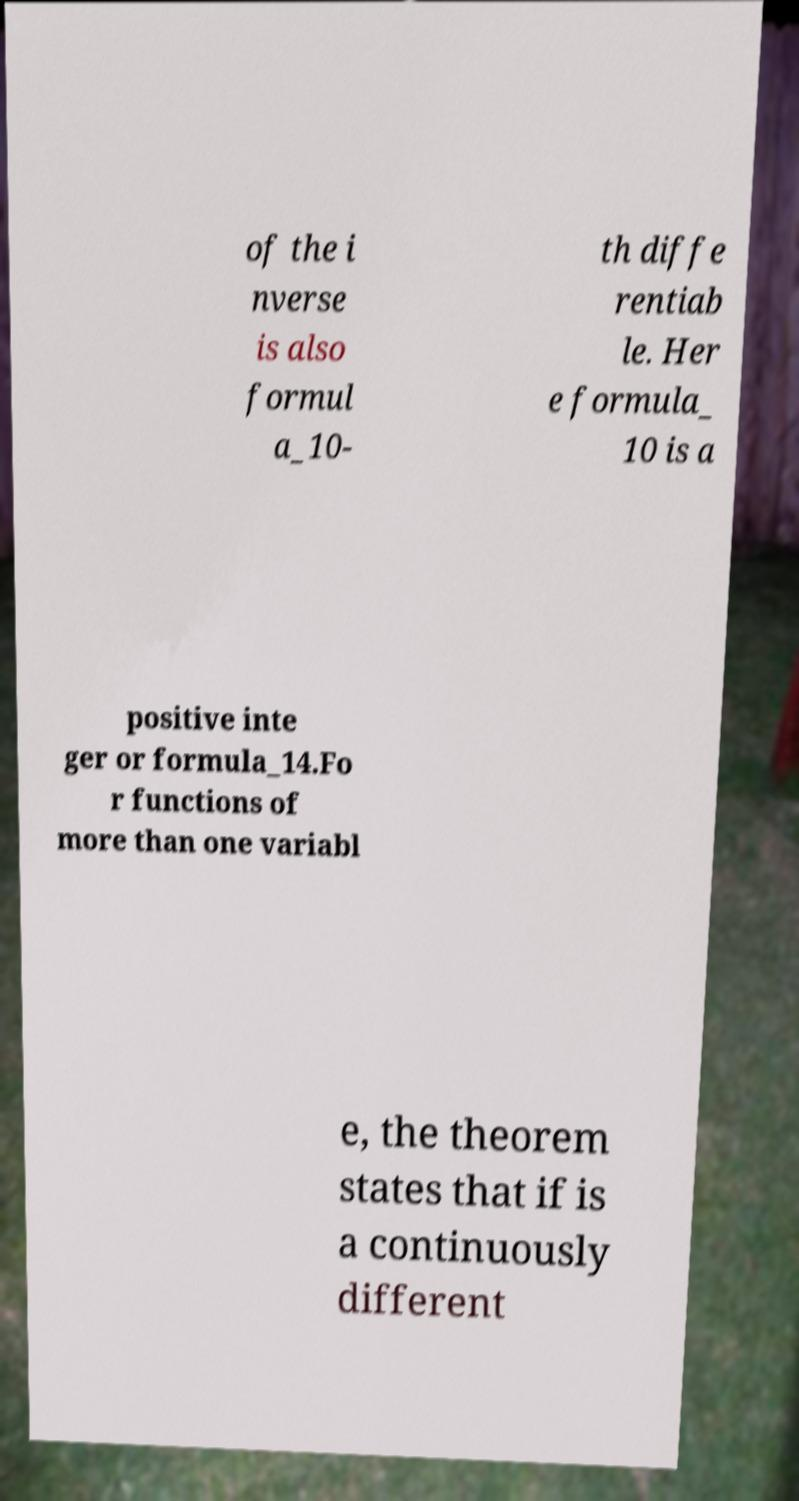There's text embedded in this image that I need extracted. Can you transcribe it verbatim? of the i nverse is also formul a_10- th diffe rentiab le. Her e formula_ 10 is a positive inte ger or formula_14.Fo r functions of more than one variabl e, the theorem states that if is a continuously different 